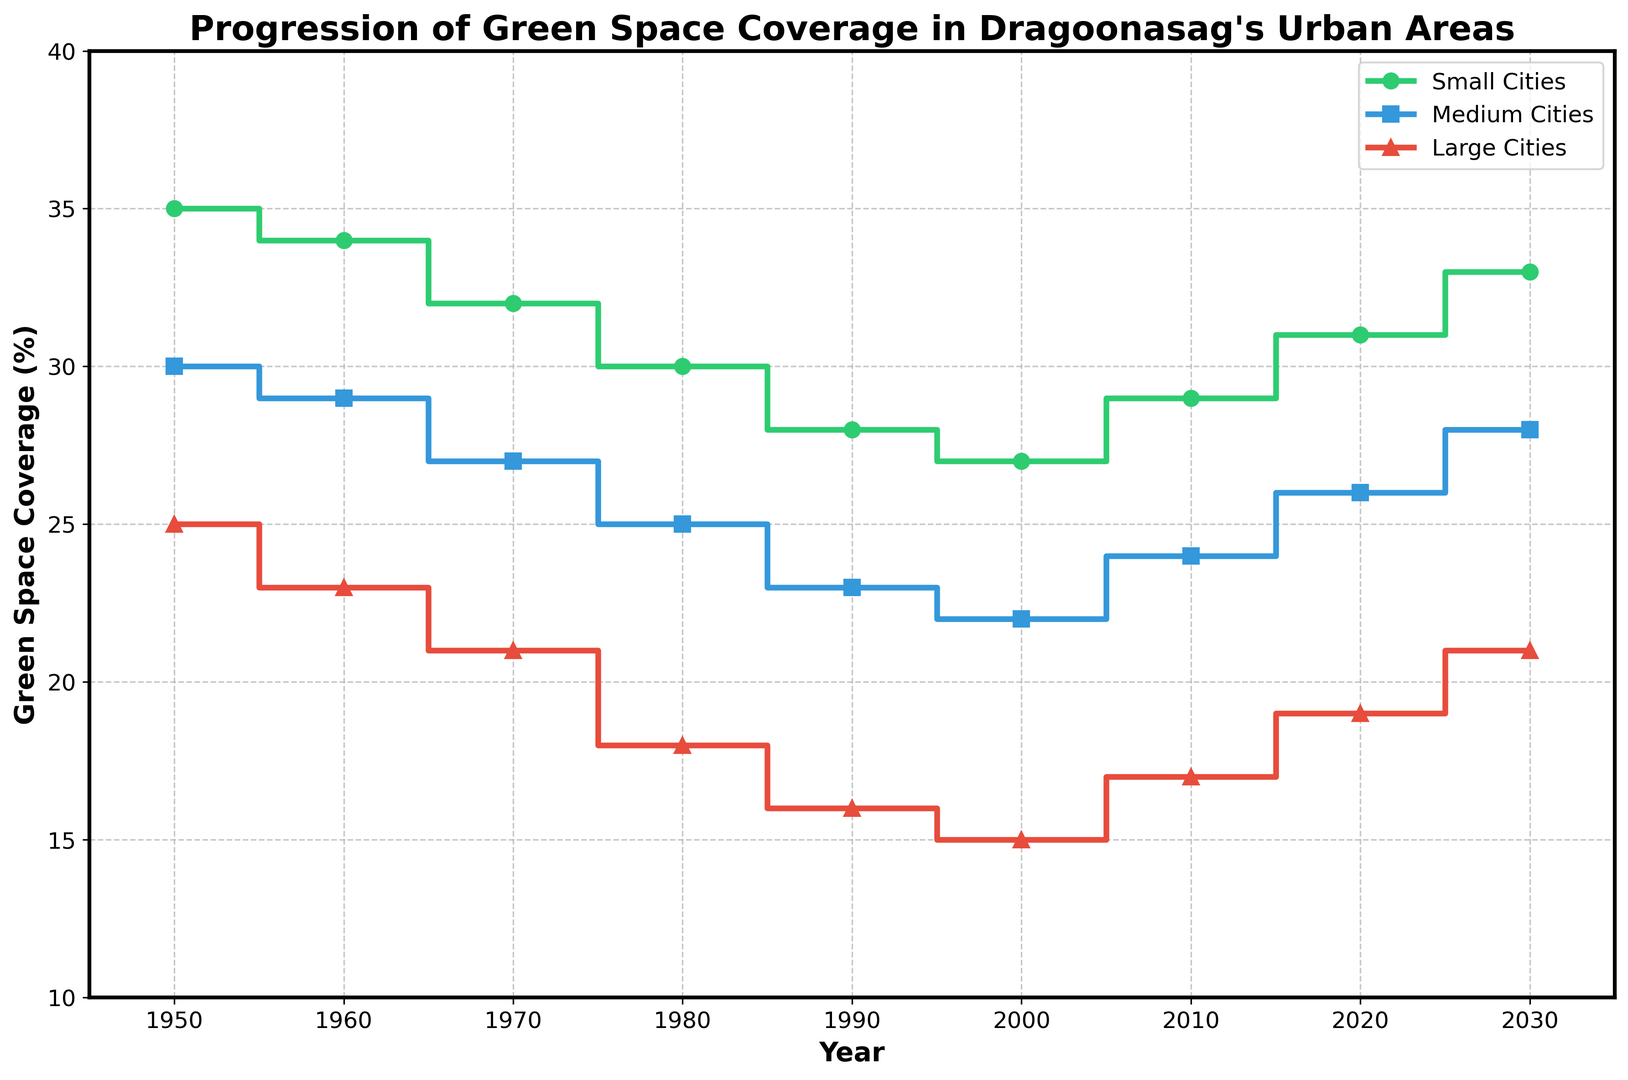What is the green space coverage for small cities in 1950? We look at the left side of the plot and identify the green line representing small cities in 1950. The line shows 35%.
Answer: 35% Between which two consecutive decades did large cities experience the steepest decline in green space coverage? Observe the red line representing large cities and measure the declines between each pair of decades. The steepest decline is from 1970 to 1980, dropping from 21% to 18%.
Answer: 1970-1980 By how many percentage points did green space coverage increase in medium cities from 2000 to 2030? Compare the values for medium cities (blue line) at 2000 and 2030. In 2000, it's 22%, and in 2030, it's 28%. The difference is 28% - 22% = 6 percentage points.
Answer: 6 percentage points Which city category had the highest green space coverage in 1980? Look at the values for 1980 across all three lines. Small cities (green) have the highest with 30%, compared to medium cities (blue) at 25% and large cities (red) at 18%.
Answer: Small Cities What is the average green space coverage for large cities across all years? Sum the values for large cities (25, 23, 21, 18, 16, 15, 17, 19, 21) and divide by the number of data points: (25+23+21+18+16+15+17+19+21)/9 = 19.44%.
Answer: 19.44% Which year had the smallest difference in green space coverage between large and small cities? Calculate the differences between large and small cities for each year and identify the smallest: 1950 (10%), 1960 (11%), 1970 (11%), 1980 (12%), 1990 (12%), 2000 (12%), 2010 (12%), 2020 (12%), 2030 (12%). The smallest difference is 10% in 1950.
Answer: 1950 In which decade did all three city categories together have the highest combined green space coverage? Sum the values across all three categories for each decade: 
1950: 35+30+25=90%, 
1960: 34+29+23=86%, 
1970: 32+27+21=80%, 
1980: 30+25+18=73%, 
1990: 28+23+16=67%, 
2000: 27+22+15=64%, 
2010: 29+24+17=70%, 
2020: 31+26+19=76%, 
2030: 33+28+21=82%. 
1950 has the highest combined coverage of 90%.
Answer: 1950 Which city size had the most significant relative increase in green space coverage from its lowest point? Determine the lowest point and highest subsequent point: 
- Small cities: lowest at 27% in 2000, increased to 33% in 2030 (22.2% increase)
- Medium cities: lowest at 22% in 2000, increased to 28% in 2030 (27.3% increase)
- Large cities: lowest at 15% in 2000, increased to 21% in 2030 (40% increase)
Large cities had the most significant relative increase from 15% to 21%.
Answer: Large Cities 